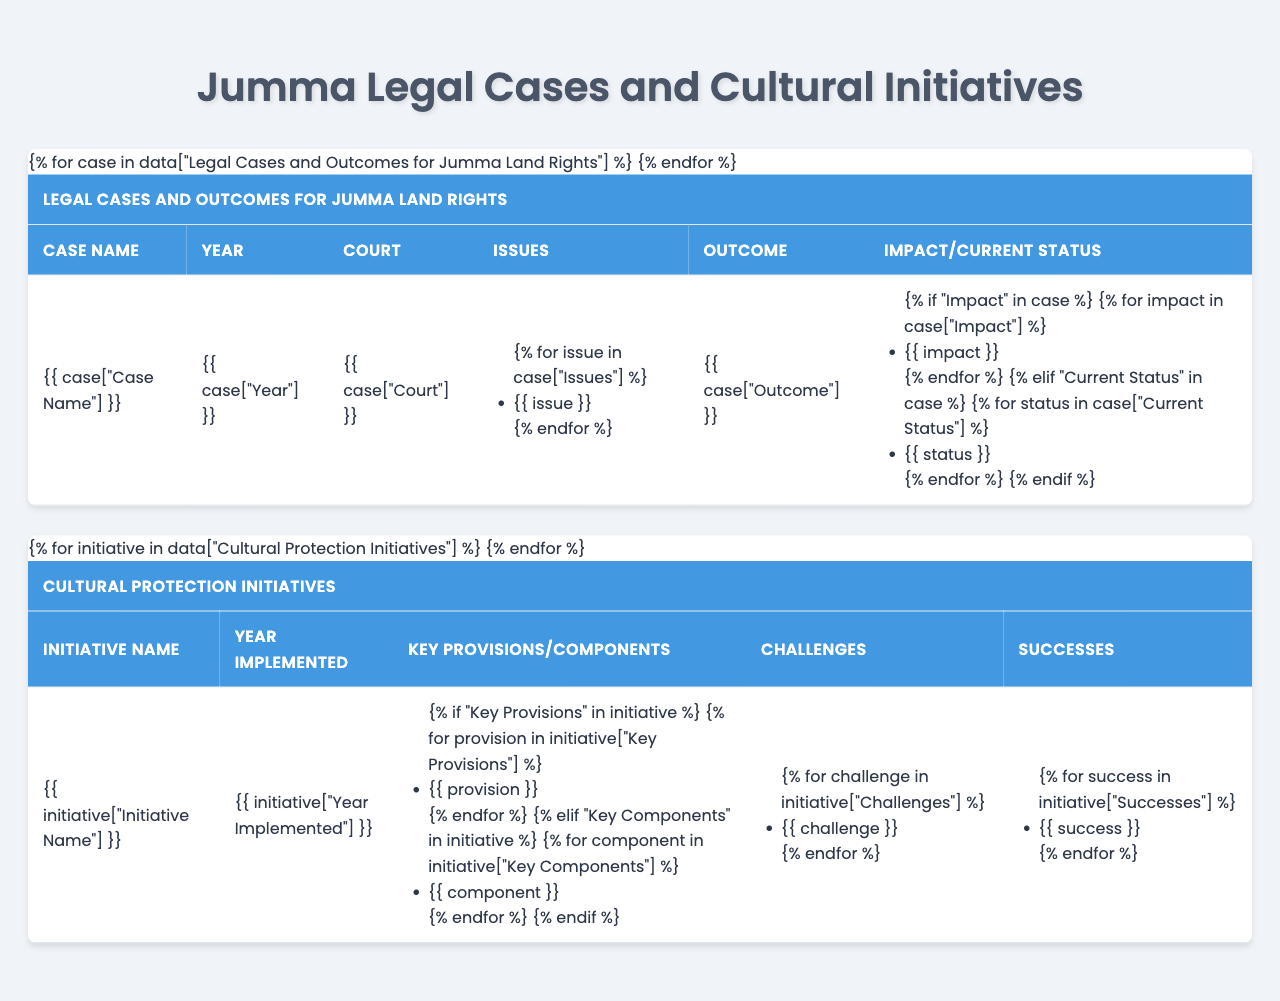What year was the "Chakma Circle vs. Bangladesh Forest Department" case? In the table, the case name is listed along with its corresponding year. The "Chakma Circle vs. Bangladesh Forest Department" case is listed under the Year column for 2015.
Answer: 2015 Which court handled the "Marma Welfare Association vs. Chittagong Hill Tracts Development Board" case? The table states the court associated with each case. The "Marma Welfare Association vs. Chittagong Hill Tracts Development Board" case was handled by the High Court Division.
Answer: High Court Division What was the outcome of the "Tripura Students Federation vs. Ministry of Land" case? Referring to the outcome section in the table, the "Tripura Students Federation vs. Ministry of Land" case is marked as ongoing.
Answer: Ongoing How many key provisions are listed for the "Jumma Language Preservation Act"? The table specifies the number of key provisions under each initiative. The "Jumma Language Preservation Act" lists three key provisions in the Key Provisions section.
Answer: Three Did any of the legal cases result in a favorable outcome for the Jumma community? To answer this, I can check the Outcomes for each legal case. The table indicates that the "Chakma Circle vs. Bangladesh Forest Department" case had a favorable outcome for the Jumma community.
Answer: Yes What were the challenges associated with the "Traditional Knowledge Digital Archive Project"? I can refer to the Challenges column in the Cultural Protection Initiatives section of the table, where the challenges for the "Traditional Knowledge Digital Archive Project" are listed as "Limited internet access in remote areas" and "Concerns about intellectual property rights."
Answer: Limited internet access and concerns about intellectual property rights Which case addressed issues of forced displacement? I look for the Issues column in the Legal Cases section. The "Marma Welfare Association vs. Chittagong Hill Tracts Development Board" case has forced displacement as one of its issues.
Answer: Marma Welfare Association vs. Chittagong Hill Tracts Development Board What success was achieved by the "Traditional Knowledge Digital Archive Project"? I check the Successes column of the Cultural Protection Initiatives section. The successes listed for the "Traditional Knowledge Digital Archive Project" include "Preservation of endangered cultural knowledge" and "Increased global awareness of Jumma heritage."
Answer: Preservation of endangered cultural knowledge and increased global awareness Which legal case was decided in favor of the Jumma community? To find this, I review the Outcomes from the legal cases. The "Chakma Circle vs. Bangladesh Forest Department" case resulted in a favorable outcome for the Jumma community.
Answer: Chakma Circle vs. Bangladesh Forest Department How many cultural initiatives were implemented after 2018? I can count the entries in the Cultural Protection Initiatives section that were initiated from 2019 onward. There are two initiatives ("Traditional Knowledge Digital Archive Project" from 2019 and another unspecified initiative).
Answer: Two 